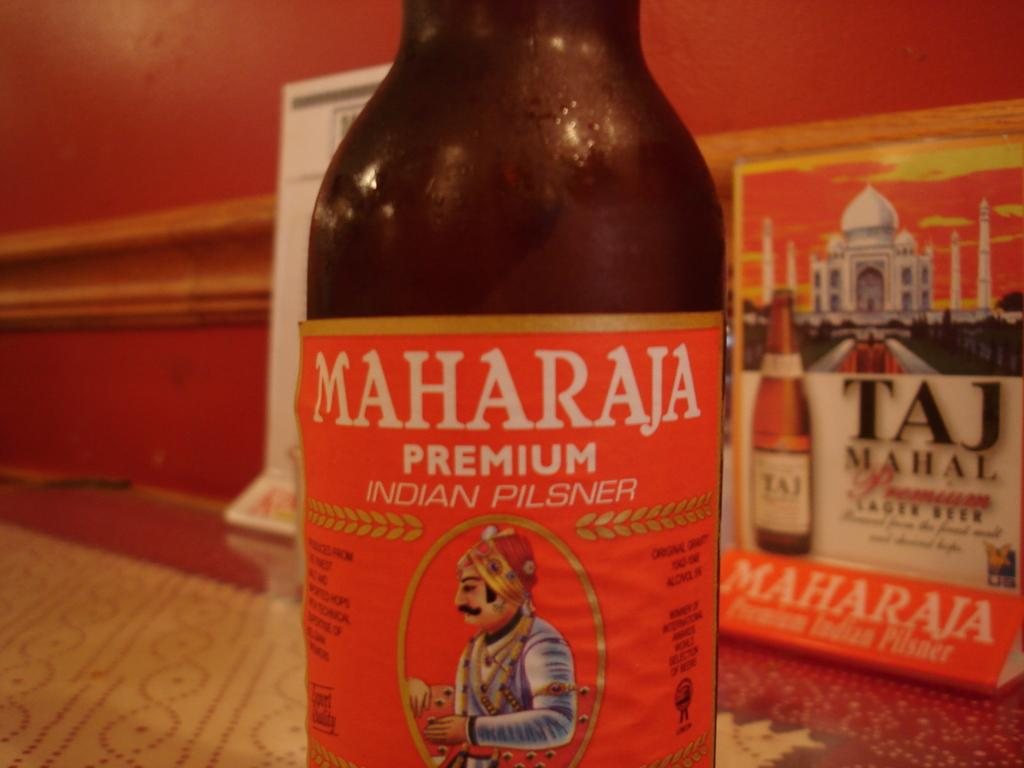<image>
Relay a brief, clear account of the picture shown. A bottle of a Maharaja pilsner sits in front of a box of Taj Mahal lager. 